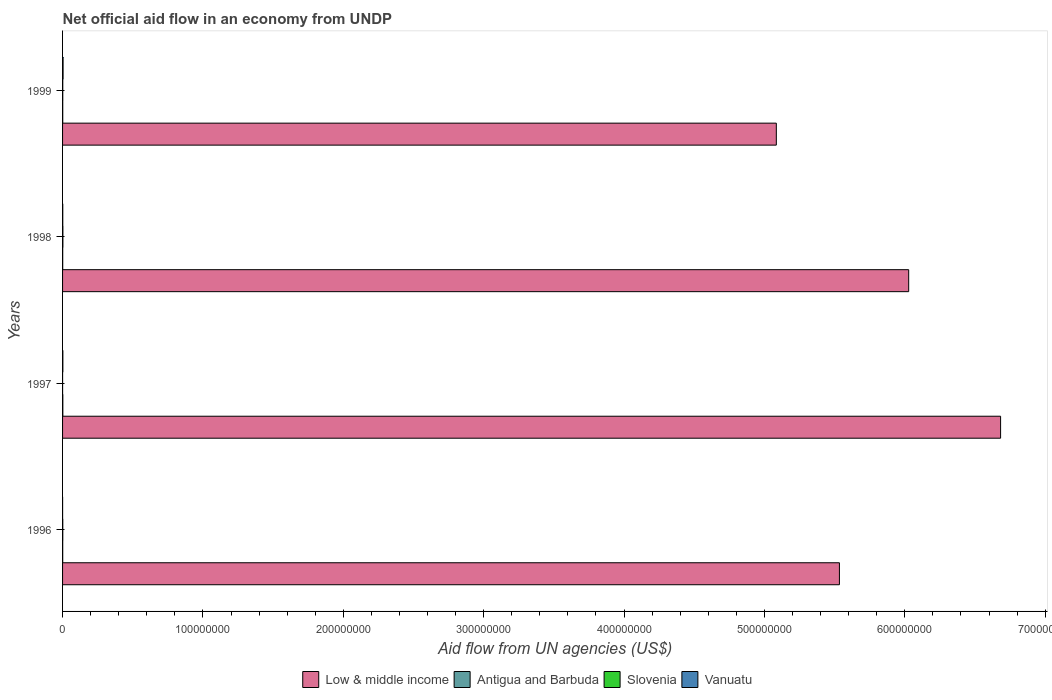Are the number of bars on each tick of the Y-axis equal?
Your response must be concise. Yes. What is the label of the 4th group of bars from the top?
Offer a very short reply. 1996. In how many cases, is the number of bars for a given year not equal to the number of legend labels?
Offer a terse response. 0. What is the net official aid flow in Low & middle income in 1998?
Give a very brief answer. 6.03e+08. Across all years, what is the maximum net official aid flow in Low & middle income?
Give a very brief answer. 6.68e+08. Across all years, what is the minimum net official aid flow in Slovenia?
Offer a terse response. 10000. In which year was the net official aid flow in Vanuatu minimum?
Your answer should be very brief. 1996. What is the total net official aid flow in Antigua and Barbuda in the graph?
Make the answer very short. 5.10e+05. What is the difference between the net official aid flow in Low & middle income in 1998 and the net official aid flow in Antigua and Barbuda in 1999?
Keep it short and to the point. 6.03e+08. What is the average net official aid flow in Slovenia per year?
Your answer should be compact. 1.32e+05. In the year 1996, what is the difference between the net official aid flow in Slovenia and net official aid flow in Low & middle income?
Ensure brevity in your answer.  -5.53e+08. In how many years, is the net official aid flow in Low & middle income greater than 200000000 US$?
Your answer should be very brief. 4. What is the ratio of the net official aid flow in Low & middle income in 1997 to that in 1998?
Your response must be concise. 1.11. Is the net official aid flow in Antigua and Barbuda in 1998 less than that in 1999?
Keep it short and to the point. Yes. Is the difference between the net official aid flow in Slovenia in 1997 and 1998 greater than the difference between the net official aid flow in Low & middle income in 1997 and 1998?
Your response must be concise. No. What is the difference between the highest and the second highest net official aid flow in Antigua and Barbuda?
Keep it short and to the point. 7.00e+04. Is the sum of the net official aid flow in Vanuatu in 1996 and 1998 greater than the maximum net official aid flow in Slovenia across all years?
Make the answer very short. No. What does the 1st bar from the top in 1999 represents?
Your answer should be compact. Vanuatu. What does the 4th bar from the bottom in 1996 represents?
Your answer should be compact. Vanuatu. How many bars are there?
Your answer should be very brief. 16. Are all the bars in the graph horizontal?
Offer a very short reply. Yes. How many years are there in the graph?
Keep it short and to the point. 4. Does the graph contain any zero values?
Your response must be concise. No. Does the graph contain grids?
Provide a short and direct response. No. How many legend labels are there?
Make the answer very short. 4. How are the legend labels stacked?
Offer a terse response. Horizontal. What is the title of the graph?
Your response must be concise. Net official aid flow in an economy from UNDP. What is the label or title of the X-axis?
Make the answer very short. Aid flow from UN agencies (US$). What is the label or title of the Y-axis?
Your response must be concise. Years. What is the Aid flow from UN agencies (US$) of Low & middle income in 1996?
Make the answer very short. 5.53e+08. What is the Aid flow from UN agencies (US$) in Slovenia in 1996?
Your response must be concise. 1.50e+05. What is the Aid flow from UN agencies (US$) in Low & middle income in 1997?
Your response must be concise. 6.68e+08. What is the Aid flow from UN agencies (US$) of Slovenia in 1997?
Keep it short and to the point. 10000. What is the Aid flow from UN agencies (US$) of Low & middle income in 1998?
Your answer should be very brief. 6.03e+08. What is the Aid flow from UN agencies (US$) of Slovenia in 1998?
Your answer should be compact. 2.30e+05. What is the Aid flow from UN agencies (US$) in Vanuatu in 1998?
Ensure brevity in your answer.  1.40e+05. What is the Aid flow from UN agencies (US$) of Low & middle income in 1999?
Your answer should be very brief. 5.08e+08. What is the Aid flow from UN agencies (US$) in Antigua and Barbuda in 1999?
Your answer should be very brief. 1.20e+05. What is the Aid flow from UN agencies (US$) in Vanuatu in 1999?
Offer a very short reply. 3.70e+05. Across all years, what is the maximum Aid flow from UN agencies (US$) in Low & middle income?
Provide a succinct answer. 6.68e+08. Across all years, what is the minimum Aid flow from UN agencies (US$) of Low & middle income?
Ensure brevity in your answer.  5.08e+08. Across all years, what is the minimum Aid flow from UN agencies (US$) in Antigua and Barbuda?
Offer a very short reply. 1.00e+05. Across all years, what is the minimum Aid flow from UN agencies (US$) of Slovenia?
Your answer should be compact. 10000. Across all years, what is the minimum Aid flow from UN agencies (US$) of Vanuatu?
Your answer should be very brief. 2.00e+04. What is the total Aid flow from UN agencies (US$) in Low & middle income in the graph?
Offer a very short reply. 2.33e+09. What is the total Aid flow from UN agencies (US$) of Antigua and Barbuda in the graph?
Your answer should be compact. 5.10e+05. What is the total Aid flow from UN agencies (US$) of Slovenia in the graph?
Your answer should be compact. 5.30e+05. What is the total Aid flow from UN agencies (US$) of Vanuatu in the graph?
Offer a terse response. 7.40e+05. What is the difference between the Aid flow from UN agencies (US$) in Low & middle income in 1996 and that in 1997?
Your response must be concise. -1.15e+08. What is the difference between the Aid flow from UN agencies (US$) of Vanuatu in 1996 and that in 1997?
Give a very brief answer. -1.90e+05. What is the difference between the Aid flow from UN agencies (US$) in Low & middle income in 1996 and that in 1998?
Your answer should be compact. -4.94e+07. What is the difference between the Aid flow from UN agencies (US$) of Vanuatu in 1996 and that in 1998?
Provide a succinct answer. -1.20e+05. What is the difference between the Aid flow from UN agencies (US$) in Low & middle income in 1996 and that in 1999?
Keep it short and to the point. 4.49e+07. What is the difference between the Aid flow from UN agencies (US$) in Antigua and Barbuda in 1996 and that in 1999?
Offer a terse response. -2.00e+04. What is the difference between the Aid flow from UN agencies (US$) of Slovenia in 1996 and that in 1999?
Provide a succinct answer. 10000. What is the difference between the Aid flow from UN agencies (US$) of Vanuatu in 1996 and that in 1999?
Give a very brief answer. -3.50e+05. What is the difference between the Aid flow from UN agencies (US$) in Low & middle income in 1997 and that in 1998?
Provide a short and direct response. 6.55e+07. What is the difference between the Aid flow from UN agencies (US$) of Slovenia in 1997 and that in 1998?
Your answer should be very brief. -2.20e+05. What is the difference between the Aid flow from UN agencies (US$) in Vanuatu in 1997 and that in 1998?
Keep it short and to the point. 7.00e+04. What is the difference between the Aid flow from UN agencies (US$) in Low & middle income in 1997 and that in 1999?
Offer a very short reply. 1.60e+08. What is the difference between the Aid flow from UN agencies (US$) of Slovenia in 1997 and that in 1999?
Your answer should be compact. -1.30e+05. What is the difference between the Aid flow from UN agencies (US$) in Low & middle income in 1998 and that in 1999?
Make the answer very short. 9.43e+07. What is the difference between the Aid flow from UN agencies (US$) of Antigua and Barbuda in 1998 and that in 1999?
Provide a succinct answer. -2.00e+04. What is the difference between the Aid flow from UN agencies (US$) of Low & middle income in 1996 and the Aid flow from UN agencies (US$) of Antigua and Barbuda in 1997?
Your response must be concise. 5.53e+08. What is the difference between the Aid flow from UN agencies (US$) of Low & middle income in 1996 and the Aid flow from UN agencies (US$) of Slovenia in 1997?
Your answer should be compact. 5.53e+08. What is the difference between the Aid flow from UN agencies (US$) of Low & middle income in 1996 and the Aid flow from UN agencies (US$) of Vanuatu in 1997?
Your answer should be very brief. 5.53e+08. What is the difference between the Aid flow from UN agencies (US$) in Antigua and Barbuda in 1996 and the Aid flow from UN agencies (US$) in Vanuatu in 1997?
Your answer should be very brief. -1.10e+05. What is the difference between the Aid flow from UN agencies (US$) in Low & middle income in 1996 and the Aid flow from UN agencies (US$) in Antigua and Barbuda in 1998?
Offer a terse response. 5.53e+08. What is the difference between the Aid flow from UN agencies (US$) of Low & middle income in 1996 and the Aid flow from UN agencies (US$) of Slovenia in 1998?
Provide a succinct answer. 5.53e+08. What is the difference between the Aid flow from UN agencies (US$) in Low & middle income in 1996 and the Aid flow from UN agencies (US$) in Vanuatu in 1998?
Your answer should be compact. 5.53e+08. What is the difference between the Aid flow from UN agencies (US$) of Antigua and Barbuda in 1996 and the Aid flow from UN agencies (US$) of Vanuatu in 1998?
Offer a terse response. -4.00e+04. What is the difference between the Aid flow from UN agencies (US$) of Low & middle income in 1996 and the Aid flow from UN agencies (US$) of Antigua and Barbuda in 1999?
Provide a succinct answer. 5.53e+08. What is the difference between the Aid flow from UN agencies (US$) of Low & middle income in 1996 and the Aid flow from UN agencies (US$) of Slovenia in 1999?
Offer a very short reply. 5.53e+08. What is the difference between the Aid flow from UN agencies (US$) in Low & middle income in 1996 and the Aid flow from UN agencies (US$) in Vanuatu in 1999?
Keep it short and to the point. 5.53e+08. What is the difference between the Aid flow from UN agencies (US$) of Low & middle income in 1997 and the Aid flow from UN agencies (US$) of Antigua and Barbuda in 1998?
Keep it short and to the point. 6.68e+08. What is the difference between the Aid flow from UN agencies (US$) of Low & middle income in 1997 and the Aid flow from UN agencies (US$) of Slovenia in 1998?
Your response must be concise. 6.68e+08. What is the difference between the Aid flow from UN agencies (US$) of Low & middle income in 1997 and the Aid flow from UN agencies (US$) of Vanuatu in 1998?
Keep it short and to the point. 6.68e+08. What is the difference between the Aid flow from UN agencies (US$) in Antigua and Barbuda in 1997 and the Aid flow from UN agencies (US$) in Vanuatu in 1998?
Offer a very short reply. 5.00e+04. What is the difference between the Aid flow from UN agencies (US$) in Low & middle income in 1997 and the Aid flow from UN agencies (US$) in Antigua and Barbuda in 1999?
Your response must be concise. 6.68e+08. What is the difference between the Aid flow from UN agencies (US$) in Low & middle income in 1997 and the Aid flow from UN agencies (US$) in Slovenia in 1999?
Make the answer very short. 6.68e+08. What is the difference between the Aid flow from UN agencies (US$) of Low & middle income in 1997 and the Aid flow from UN agencies (US$) of Vanuatu in 1999?
Provide a succinct answer. 6.68e+08. What is the difference between the Aid flow from UN agencies (US$) in Antigua and Barbuda in 1997 and the Aid flow from UN agencies (US$) in Slovenia in 1999?
Your answer should be very brief. 5.00e+04. What is the difference between the Aid flow from UN agencies (US$) in Antigua and Barbuda in 1997 and the Aid flow from UN agencies (US$) in Vanuatu in 1999?
Give a very brief answer. -1.80e+05. What is the difference between the Aid flow from UN agencies (US$) of Slovenia in 1997 and the Aid flow from UN agencies (US$) of Vanuatu in 1999?
Your response must be concise. -3.60e+05. What is the difference between the Aid flow from UN agencies (US$) of Low & middle income in 1998 and the Aid flow from UN agencies (US$) of Antigua and Barbuda in 1999?
Give a very brief answer. 6.03e+08. What is the difference between the Aid flow from UN agencies (US$) of Low & middle income in 1998 and the Aid flow from UN agencies (US$) of Slovenia in 1999?
Provide a short and direct response. 6.03e+08. What is the difference between the Aid flow from UN agencies (US$) of Low & middle income in 1998 and the Aid flow from UN agencies (US$) of Vanuatu in 1999?
Provide a short and direct response. 6.02e+08. What is the difference between the Aid flow from UN agencies (US$) in Antigua and Barbuda in 1998 and the Aid flow from UN agencies (US$) in Slovenia in 1999?
Make the answer very short. -4.00e+04. What is the difference between the Aid flow from UN agencies (US$) of Antigua and Barbuda in 1998 and the Aid flow from UN agencies (US$) of Vanuatu in 1999?
Keep it short and to the point. -2.70e+05. What is the difference between the Aid flow from UN agencies (US$) in Slovenia in 1998 and the Aid flow from UN agencies (US$) in Vanuatu in 1999?
Keep it short and to the point. -1.40e+05. What is the average Aid flow from UN agencies (US$) in Low & middle income per year?
Your answer should be very brief. 5.83e+08. What is the average Aid flow from UN agencies (US$) of Antigua and Barbuda per year?
Make the answer very short. 1.28e+05. What is the average Aid flow from UN agencies (US$) of Slovenia per year?
Offer a terse response. 1.32e+05. What is the average Aid flow from UN agencies (US$) of Vanuatu per year?
Provide a succinct answer. 1.85e+05. In the year 1996, what is the difference between the Aid flow from UN agencies (US$) of Low & middle income and Aid flow from UN agencies (US$) of Antigua and Barbuda?
Make the answer very short. 5.53e+08. In the year 1996, what is the difference between the Aid flow from UN agencies (US$) in Low & middle income and Aid flow from UN agencies (US$) in Slovenia?
Offer a very short reply. 5.53e+08. In the year 1996, what is the difference between the Aid flow from UN agencies (US$) of Low & middle income and Aid flow from UN agencies (US$) of Vanuatu?
Offer a terse response. 5.53e+08. In the year 1996, what is the difference between the Aid flow from UN agencies (US$) in Antigua and Barbuda and Aid flow from UN agencies (US$) in Slovenia?
Ensure brevity in your answer.  -5.00e+04. In the year 1996, what is the difference between the Aid flow from UN agencies (US$) of Slovenia and Aid flow from UN agencies (US$) of Vanuatu?
Provide a succinct answer. 1.30e+05. In the year 1997, what is the difference between the Aid flow from UN agencies (US$) in Low & middle income and Aid flow from UN agencies (US$) in Antigua and Barbuda?
Your answer should be very brief. 6.68e+08. In the year 1997, what is the difference between the Aid flow from UN agencies (US$) of Low & middle income and Aid flow from UN agencies (US$) of Slovenia?
Ensure brevity in your answer.  6.68e+08. In the year 1997, what is the difference between the Aid flow from UN agencies (US$) in Low & middle income and Aid flow from UN agencies (US$) in Vanuatu?
Provide a succinct answer. 6.68e+08. In the year 1997, what is the difference between the Aid flow from UN agencies (US$) in Slovenia and Aid flow from UN agencies (US$) in Vanuatu?
Make the answer very short. -2.00e+05. In the year 1998, what is the difference between the Aid flow from UN agencies (US$) in Low & middle income and Aid flow from UN agencies (US$) in Antigua and Barbuda?
Ensure brevity in your answer.  6.03e+08. In the year 1998, what is the difference between the Aid flow from UN agencies (US$) in Low & middle income and Aid flow from UN agencies (US$) in Slovenia?
Keep it short and to the point. 6.03e+08. In the year 1998, what is the difference between the Aid flow from UN agencies (US$) in Low & middle income and Aid flow from UN agencies (US$) in Vanuatu?
Provide a succinct answer. 6.03e+08. In the year 1998, what is the difference between the Aid flow from UN agencies (US$) in Antigua and Barbuda and Aid flow from UN agencies (US$) in Slovenia?
Offer a very short reply. -1.30e+05. In the year 1998, what is the difference between the Aid flow from UN agencies (US$) of Antigua and Barbuda and Aid flow from UN agencies (US$) of Vanuatu?
Provide a succinct answer. -4.00e+04. In the year 1998, what is the difference between the Aid flow from UN agencies (US$) of Slovenia and Aid flow from UN agencies (US$) of Vanuatu?
Your response must be concise. 9.00e+04. In the year 1999, what is the difference between the Aid flow from UN agencies (US$) in Low & middle income and Aid flow from UN agencies (US$) in Antigua and Barbuda?
Offer a terse response. 5.08e+08. In the year 1999, what is the difference between the Aid flow from UN agencies (US$) in Low & middle income and Aid flow from UN agencies (US$) in Slovenia?
Your answer should be very brief. 5.08e+08. In the year 1999, what is the difference between the Aid flow from UN agencies (US$) of Low & middle income and Aid flow from UN agencies (US$) of Vanuatu?
Make the answer very short. 5.08e+08. In the year 1999, what is the difference between the Aid flow from UN agencies (US$) in Antigua and Barbuda and Aid flow from UN agencies (US$) in Slovenia?
Ensure brevity in your answer.  -2.00e+04. In the year 1999, what is the difference between the Aid flow from UN agencies (US$) in Antigua and Barbuda and Aid flow from UN agencies (US$) in Vanuatu?
Provide a short and direct response. -2.50e+05. In the year 1999, what is the difference between the Aid flow from UN agencies (US$) in Slovenia and Aid flow from UN agencies (US$) in Vanuatu?
Provide a short and direct response. -2.30e+05. What is the ratio of the Aid flow from UN agencies (US$) in Low & middle income in 1996 to that in 1997?
Your answer should be compact. 0.83. What is the ratio of the Aid flow from UN agencies (US$) of Antigua and Barbuda in 1996 to that in 1997?
Ensure brevity in your answer.  0.53. What is the ratio of the Aid flow from UN agencies (US$) in Slovenia in 1996 to that in 1997?
Your answer should be very brief. 15. What is the ratio of the Aid flow from UN agencies (US$) in Vanuatu in 1996 to that in 1997?
Ensure brevity in your answer.  0.1. What is the ratio of the Aid flow from UN agencies (US$) in Low & middle income in 1996 to that in 1998?
Your response must be concise. 0.92. What is the ratio of the Aid flow from UN agencies (US$) in Slovenia in 1996 to that in 1998?
Provide a succinct answer. 0.65. What is the ratio of the Aid flow from UN agencies (US$) of Vanuatu in 1996 to that in 1998?
Make the answer very short. 0.14. What is the ratio of the Aid flow from UN agencies (US$) in Low & middle income in 1996 to that in 1999?
Offer a terse response. 1.09. What is the ratio of the Aid flow from UN agencies (US$) of Antigua and Barbuda in 1996 to that in 1999?
Ensure brevity in your answer.  0.83. What is the ratio of the Aid flow from UN agencies (US$) in Slovenia in 1996 to that in 1999?
Make the answer very short. 1.07. What is the ratio of the Aid flow from UN agencies (US$) of Vanuatu in 1996 to that in 1999?
Ensure brevity in your answer.  0.05. What is the ratio of the Aid flow from UN agencies (US$) of Low & middle income in 1997 to that in 1998?
Your answer should be very brief. 1.11. What is the ratio of the Aid flow from UN agencies (US$) of Antigua and Barbuda in 1997 to that in 1998?
Your answer should be compact. 1.9. What is the ratio of the Aid flow from UN agencies (US$) in Slovenia in 1997 to that in 1998?
Offer a terse response. 0.04. What is the ratio of the Aid flow from UN agencies (US$) in Vanuatu in 1997 to that in 1998?
Provide a succinct answer. 1.5. What is the ratio of the Aid flow from UN agencies (US$) in Low & middle income in 1997 to that in 1999?
Offer a very short reply. 1.31. What is the ratio of the Aid flow from UN agencies (US$) in Antigua and Barbuda in 1997 to that in 1999?
Your answer should be very brief. 1.58. What is the ratio of the Aid flow from UN agencies (US$) in Slovenia in 1997 to that in 1999?
Provide a succinct answer. 0.07. What is the ratio of the Aid flow from UN agencies (US$) of Vanuatu in 1997 to that in 1999?
Your answer should be very brief. 0.57. What is the ratio of the Aid flow from UN agencies (US$) in Low & middle income in 1998 to that in 1999?
Ensure brevity in your answer.  1.19. What is the ratio of the Aid flow from UN agencies (US$) of Antigua and Barbuda in 1998 to that in 1999?
Provide a succinct answer. 0.83. What is the ratio of the Aid flow from UN agencies (US$) of Slovenia in 1998 to that in 1999?
Offer a very short reply. 1.64. What is the ratio of the Aid flow from UN agencies (US$) in Vanuatu in 1998 to that in 1999?
Your response must be concise. 0.38. What is the difference between the highest and the second highest Aid flow from UN agencies (US$) in Low & middle income?
Your answer should be very brief. 6.55e+07. What is the difference between the highest and the lowest Aid flow from UN agencies (US$) in Low & middle income?
Your response must be concise. 1.60e+08. What is the difference between the highest and the lowest Aid flow from UN agencies (US$) in Slovenia?
Provide a short and direct response. 2.20e+05. 